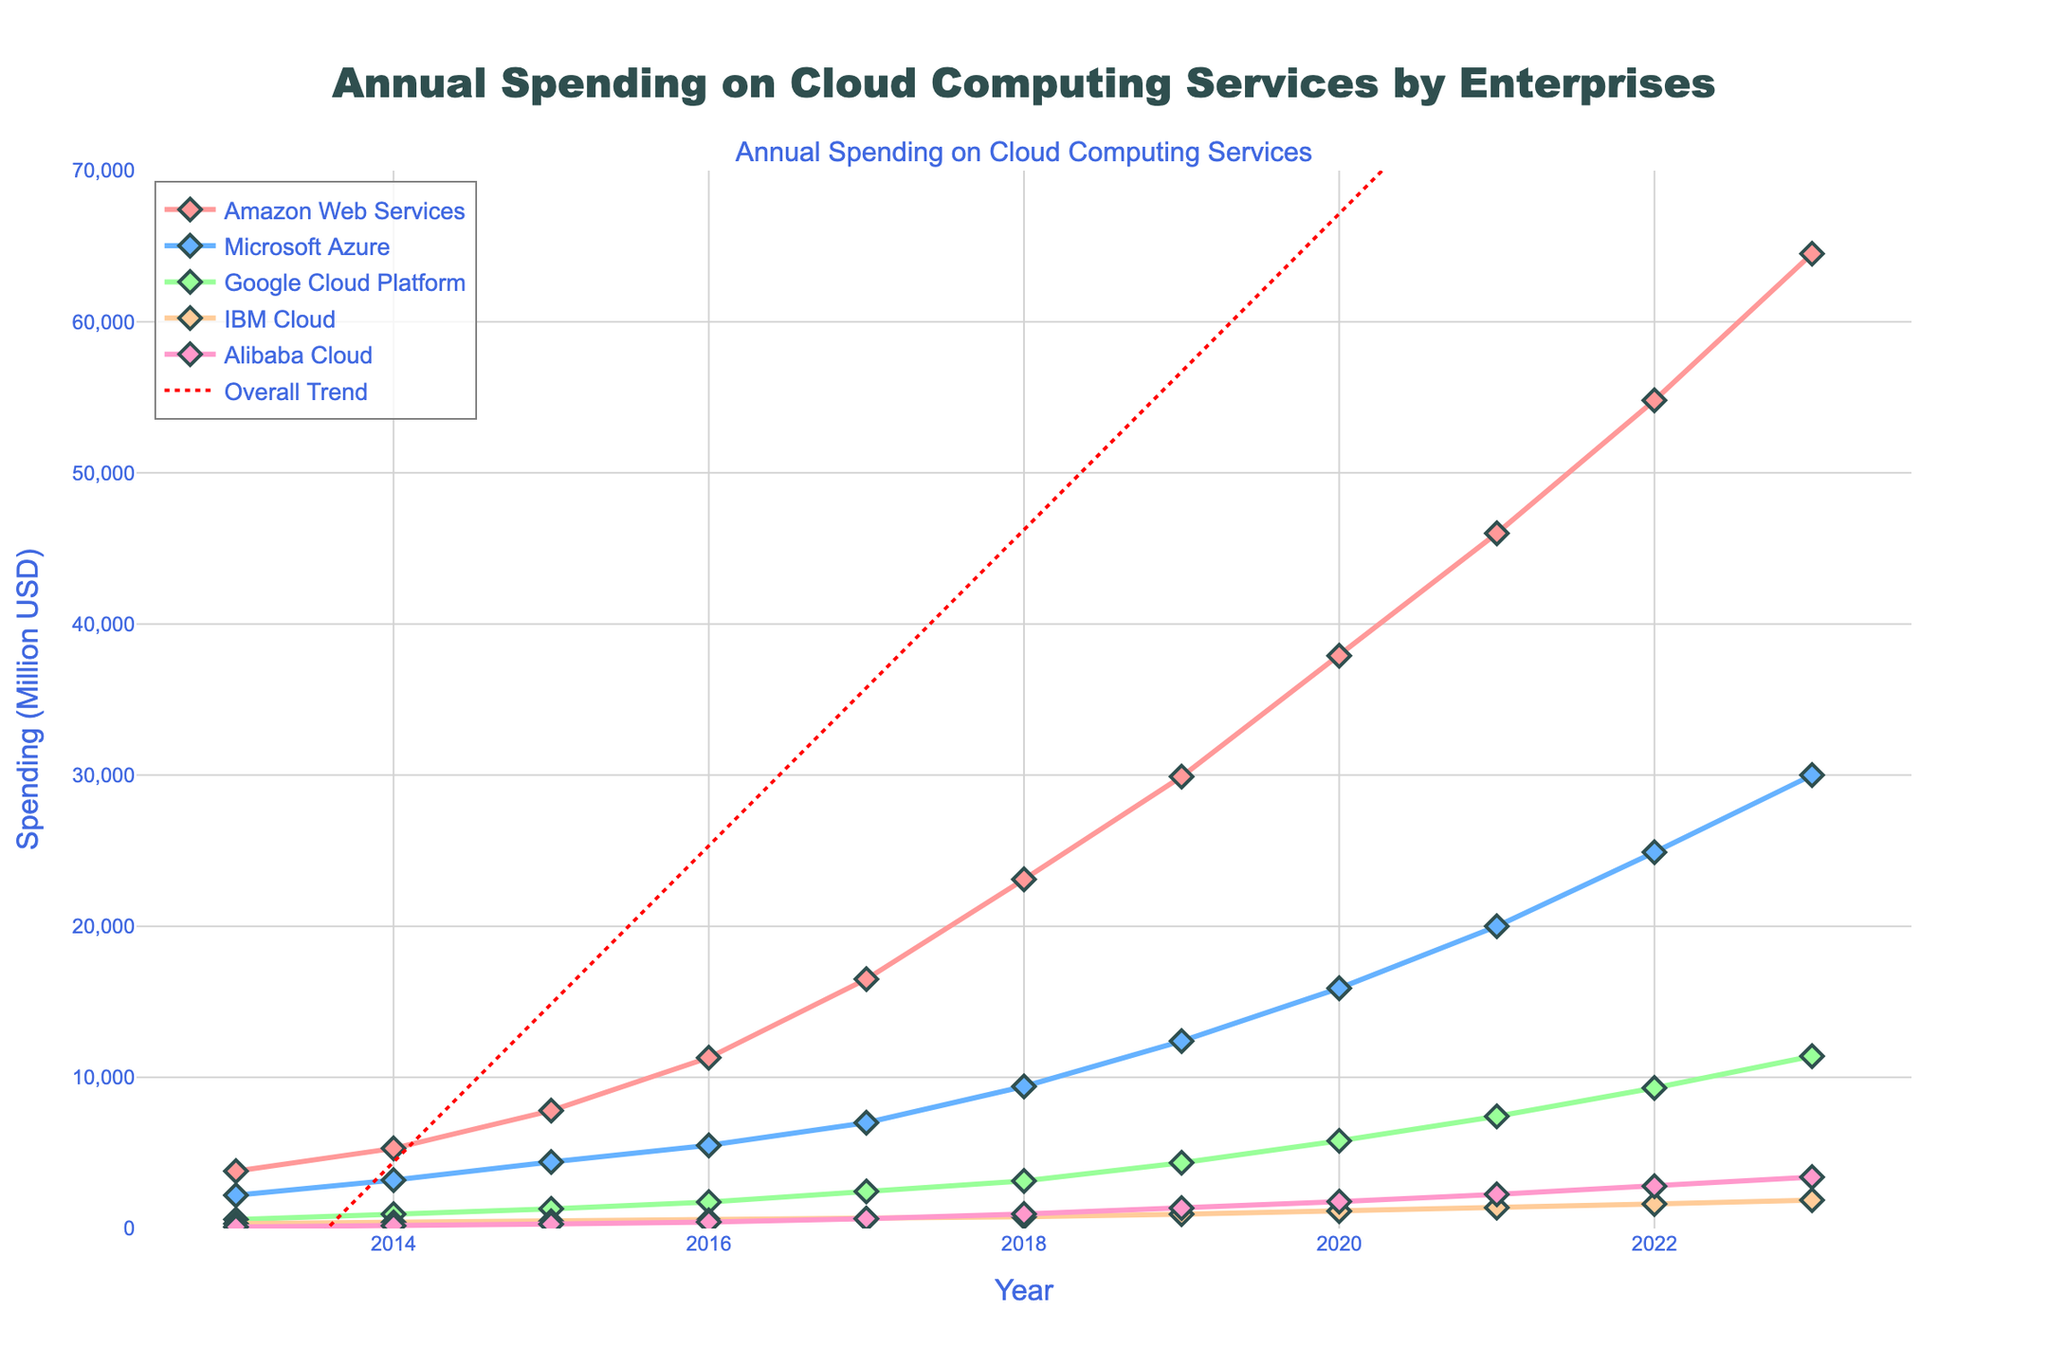Which company had the highest spending on cloud computing services in 2023? Looking at the 2023 data points, the highest value among the provided companies is from Amazon Web Services.
Answer: Amazon Web Services What is the overall trend line indicating about the total spending on cloud computing services? The overall trend line is a red, dotted line which visually shows an upward trend in total spending over the ten-year period.
Answer: Upward trend By how much did Microsoft's cloud computing spending increase from 2013 to 2023? To find the increase, subtract the 2013 spending from the 2023 spending for Microsoft Azure. 30000 (in 2023) - 2200 (in 2013) = 27800.
Answer: 27800 million USD In which year did IBM Cloud surpass 1000 million USD in spending? Check the IBM Cloud data series and find the first year where the value exceeds 1000 million USD, which is in 2020.
Answer: 2020 Which two companies had the closest spending amounts in 2017? Compare the 2017 values for each company. The closest spending amounts in 2017 are between Google Cloud Platform (2450) and IBM Cloud (640).
Answer: Google Cloud Platform and IBM Cloud What was Google's spending on cloud computing services in 2019, and how does it compare to Alibaba Cloud's spending in the same year? For 2019, Google's spending was 4350 and Alibaba Cloud's was 1350. Google spent 4350 - 1350 = 3000 million USD more than Alibaba Cloud.
Answer: 3000 million USD more Which company showed the most significant relative growth from 2013 to 2023? Calculate the growth for each company by dividing the difference between 2023 and 2013 values by the 2013 value. The highest relative growth percentage indicates the most significant growth. Relative growth = (Final - Initial) / Initial x 100%. For Alibaba Cloud: (3400-100)/100 = 3300%, for AWS: (64500-3800)/3800 = 1597.37%, for Azure: (30000-2200)/2200 = 1272.73%, for Google Cloud: (11400-600)/600 = 1800%, for IBM Cloud: (1880-320)/320 = 487.5%. Alibaba Cloud had the most significant growth.
Answer: Alibaba Cloud What was the total spending on cloud computing services by all companies in 2016? Sum the spending of all companies in 2016: 11300 (AWS) + 5500 (Azure) + 1750 (Google) + 540 (IBM) + 430 (Alibaba) = 19520 million USD.
Answer: 19520 million USD How did Alibaba Cloud's spending trend compare to IBM Cloud from 2013 to 2023? Compare the line charts of Alibaba Cloud and IBM Cloud. Both show an increasing trend, but Alibaba Cloud's increase is sharper and starts at a lower 2013 value.
Answer: Alibaba Cloud had a sharper increase What was the average annual spending on cloud services for Google Cloud Platform over the last 10 years? Calculate the sum of Google's spending from 2013 to 2023 and divide it by 11 years: (600 + 950 + 1300 + 1750 + 2450 + 3150 + 4350 + 5800 + 7420 + 9300 + 11400)/11 = 4393.64 million USD.
Answer: 4393.64 million USD 